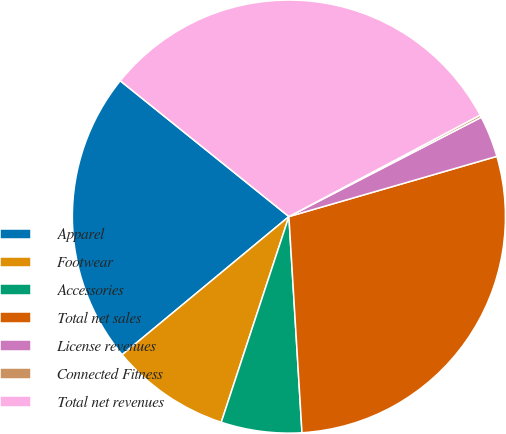Convert chart to OTSL. <chart><loc_0><loc_0><loc_500><loc_500><pie_chart><fcel>Apparel<fcel>Footwear<fcel>Accessories<fcel>Total net sales<fcel>License revenues<fcel>Connected Fitness<fcel>Total net revenues<nl><fcel>21.8%<fcel>8.93%<fcel>6.02%<fcel>28.52%<fcel>3.1%<fcel>0.18%<fcel>31.44%<nl></chart> 